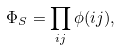Convert formula to latex. <formula><loc_0><loc_0><loc_500><loc_500>\Phi _ { S } = \prod _ { i j } \phi ( i j ) ,</formula> 